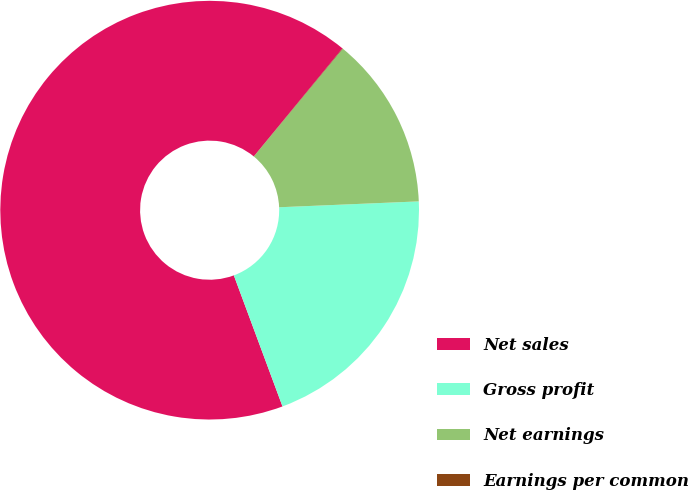<chart> <loc_0><loc_0><loc_500><loc_500><pie_chart><fcel>Net sales<fcel>Gross profit<fcel>Net earnings<fcel>Earnings per common<nl><fcel>66.6%<fcel>20.01%<fcel>13.35%<fcel>0.04%<nl></chart> 